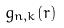Convert formula to latex. <formula><loc_0><loc_0><loc_500><loc_500>g _ { n , k } ( r )</formula> 